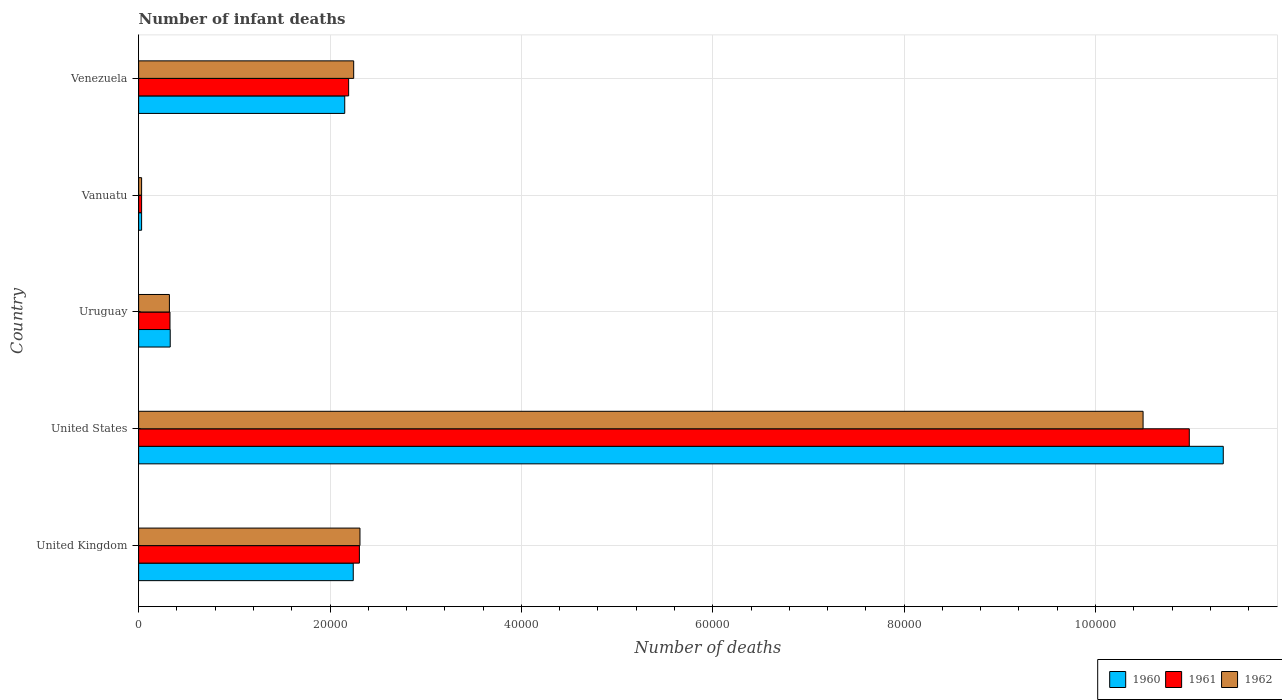Are the number of bars per tick equal to the number of legend labels?
Provide a short and direct response. Yes. Are the number of bars on each tick of the Y-axis equal?
Ensure brevity in your answer.  Yes. How many bars are there on the 4th tick from the top?
Your answer should be compact. 3. What is the label of the 4th group of bars from the top?
Give a very brief answer. United States. What is the number of infant deaths in 1961 in Uruguay?
Your answer should be very brief. 3277. Across all countries, what is the maximum number of infant deaths in 1960?
Offer a terse response. 1.13e+05. Across all countries, what is the minimum number of infant deaths in 1961?
Give a very brief answer. 311. In which country was the number of infant deaths in 1961 minimum?
Your answer should be compact. Vanuatu. What is the total number of infant deaths in 1961 in the graph?
Provide a short and direct response. 1.58e+05. What is the difference between the number of infant deaths in 1962 in United Kingdom and that in Uruguay?
Ensure brevity in your answer.  1.99e+04. What is the difference between the number of infant deaths in 1962 in United Kingdom and the number of infant deaths in 1961 in United States?
Offer a terse response. -8.67e+04. What is the average number of infant deaths in 1961 per country?
Ensure brevity in your answer.  3.17e+04. What is the difference between the number of infant deaths in 1960 and number of infant deaths in 1962 in United States?
Ensure brevity in your answer.  8380. What is the ratio of the number of infant deaths in 1961 in Uruguay to that in Venezuela?
Offer a terse response. 0.15. Is the difference between the number of infant deaths in 1960 in United States and Uruguay greater than the difference between the number of infant deaths in 1962 in United States and Uruguay?
Provide a succinct answer. Yes. What is the difference between the highest and the second highest number of infant deaths in 1960?
Offer a terse response. 9.09e+04. What is the difference between the highest and the lowest number of infant deaths in 1962?
Provide a short and direct response. 1.05e+05. In how many countries, is the number of infant deaths in 1960 greater than the average number of infant deaths in 1960 taken over all countries?
Offer a terse response. 1. Is the sum of the number of infant deaths in 1962 in United Kingdom and Venezuela greater than the maximum number of infant deaths in 1961 across all countries?
Offer a very short reply. No. What does the 3rd bar from the top in Venezuela represents?
Your response must be concise. 1960. What does the 2nd bar from the bottom in Venezuela represents?
Provide a short and direct response. 1961. What is the difference between two consecutive major ticks on the X-axis?
Make the answer very short. 2.00e+04. Does the graph contain any zero values?
Give a very brief answer. No. Where does the legend appear in the graph?
Offer a very short reply. Bottom right. How many legend labels are there?
Give a very brief answer. 3. How are the legend labels stacked?
Your answer should be compact. Horizontal. What is the title of the graph?
Your answer should be compact. Number of infant deaths. Does "2004" appear as one of the legend labels in the graph?
Ensure brevity in your answer.  No. What is the label or title of the X-axis?
Your response must be concise. Number of deaths. What is the label or title of the Y-axis?
Offer a terse response. Country. What is the Number of deaths in 1960 in United Kingdom?
Offer a very short reply. 2.24e+04. What is the Number of deaths of 1961 in United Kingdom?
Your answer should be very brief. 2.31e+04. What is the Number of deaths of 1962 in United Kingdom?
Offer a terse response. 2.31e+04. What is the Number of deaths of 1960 in United States?
Offer a very short reply. 1.13e+05. What is the Number of deaths of 1961 in United States?
Your answer should be very brief. 1.10e+05. What is the Number of deaths of 1962 in United States?
Your response must be concise. 1.05e+05. What is the Number of deaths in 1960 in Uruguay?
Give a very brief answer. 3301. What is the Number of deaths of 1961 in Uruguay?
Provide a short and direct response. 3277. What is the Number of deaths of 1962 in Uruguay?
Provide a short and direct response. 3216. What is the Number of deaths in 1960 in Vanuatu?
Give a very brief answer. 311. What is the Number of deaths of 1961 in Vanuatu?
Give a very brief answer. 311. What is the Number of deaths of 1962 in Vanuatu?
Give a very brief answer. 311. What is the Number of deaths in 1960 in Venezuela?
Your answer should be compact. 2.15e+04. What is the Number of deaths of 1961 in Venezuela?
Your response must be concise. 2.19e+04. What is the Number of deaths in 1962 in Venezuela?
Make the answer very short. 2.25e+04. Across all countries, what is the maximum Number of deaths of 1960?
Your answer should be very brief. 1.13e+05. Across all countries, what is the maximum Number of deaths in 1961?
Ensure brevity in your answer.  1.10e+05. Across all countries, what is the maximum Number of deaths of 1962?
Give a very brief answer. 1.05e+05. Across all countries, what is the minimum Number of deaths in 1960?
Keep it short and to the point. 311. Across all countries, what is the minimum Number of deaths of 1961?
Provide a short and direct response. 311. Across all countries, what is the minimum Number of deaths in 1962?
Keep it short and to the point. 311. What is the total Number of deaths of 1960 in the graph?
Offer a very short reply. 1.61e+05. What is the total Number of deaths in 1961 in the graph?
Offer a terse response. 1.58e+05. What is the total Number of deaths of 1962 in the graph?
Provide a succinct answer. 1.54e+05. What is the difference between the Number of deaths in 1960 in United Kingdom and that in United States?
Make the answer very short. -9.09e+04. What is the difference between the Number of deaths of 1961 in United Kingdom and that in United States?
Provide a short and direct response. -8.67e+04. What is the difference between the Number of deaths of 1962 in United Kingdom and that in United States?
Provide a succinct answer. -8.18e+04. What is the difference between the Number of deaths in 1960 in United Kingdom and that in Uruguay?
Offer a very short reply. 1.91e+04. What is the difference between the Number of deaths of 1961 in United Kingdom and that in Uruguay?
Provide a short and direct response. 1.98e+04. What is the difference between the Number of deaths of 1962 in United Kingdom and that in Uruguay?
Offer a very short reply. 1.99e+04. What is the difference between the Number of deaths of 1960 in United Kingdom and that in Vanuatu?
Offer a very short reply. 2.21e+04. What is the difference between the Number of deaths of 1961 in United Kingdom and that in Vanuatu?
Provide a succinct answer. 2.28e+04. What is the difference between the Number of deaths in 1962 in United Kingdom and that in Vanuatu?
Make the answer very short. 2.28e+04. What is the difference between the Number of deaths of 1960 in United Kingdom and that in Venezuela?
Your response must be concise. 890. What is the difference between the Number of deaths in 1961 in United Kingdom and that in Venezuela?
Keep it short and to the point. 1124. What is the difference between the Number of deaths of 1962 in United Kingdom and that in Venezuela?
Make the answer very short. 657. What is the difference between the Number of deaths in 1960 in United States and that in Uruguay?
Offer a terse response. 1.10e+05. What is the difference between the Number of deaths of 1961 in United States and that in Uruguay?
Make the answer very short. 1.07e+05. What is the difference between the Number of deaths in 1962 in United States and that in Uruguay?
Offer a very short reply. 1.02e+05. What is the difference between the Number of deaths in 1960 in United States and that in Vanuatu?
Offer a terse response. 1.13e+05. What is the difference between the Number of deaths of 1961 in United States and that in Vanuatu?
Ensure brevity in your answer.  1.09e+05. What is the difference between the Number of deaths of 1962 in United States and that in Vanuatu?
Your answer should be compact. 1.05e+05. What is the difference between the Number of deaths in 1960 in United States and that in Venezuela?
Provide a short and direct response. 9.18e+04. What is the difference between the Number of deaths of 1961 in United States and that in Venezuela?
Make the answer very short. 8.79e+04. What is the difference between the Number of deaths of 1962 in United States and that in Venezuela?
Ensure brevity in your answer.  8.25e+04. What is the difference between the Number of deaths of 1960 in Uruguay and that in Vanuatu?
Provide a short and direct response. 2990. What is the difference between the Number of deaths in 1961 in Uruguay and that in Vanuatu?
Offer a very short reply. 2966. What is the difference between the Number of deaths of 1962 in Uruguay and that in Vanuatu?
Ensure brevity in your answer.  2905. What is the difference between the Number of deaths in 1960 in Uruguay and that in Venezuela?
Give a very brief answer. -1.82e+04. What is the difference between the Number of deaths of 1961 in Uruguay and that in Venezuela?
Make the answer very short. -1.87e+04. What is the difference between the Number of deaths of 1962 in Uruguay and that in Venezuela?
Provide a short and direct response. -1.93e+04. What is the difference between the Number of deaths in 1960 in Vanuatu and that in Venezuela?
Provide a short and direct response. -2.12e+04. What is the difference between the Number of deaths in 1961 in Vanuatu and that in Venezuela?
Make the answer very short. -2.16e+04. What is the difference between the Number of deaths in 1962 in Vanuatu and that in Venezuela?
Offer a terse response. -2.22e+04. What is the difference between the Number of deaths of 1960 in United Kingdom and the Number of deaths of 1961 in United States?
Offer a very short reply. -8.74e+04. What is the difference between the Number of deaths in 1960 in United Kingdom and the Number of deaths in 1962 in United States?
Provide a succinct answer. -8.25e+04. What is the difference between the Number of deaths of 1961 in United Kingdom and the Number of deaths of 1962 in United States?
Keep it short and to the point. -8.19e+04. What is the difference between the Number of deaths in 1960 in United Kingdom and the Number of deaths in 1961 in Uruguay?
Make the answer very short. 1.92e+04. What is the difference between the Number of deaths of 1960 in United Kingdom and the Number of deaths of 1962 in Uruguay?
Offer a terse response. 1.92e+04. What is the difference between the Number of deaths of 1961 in United Kingdom and the Number of deaths of 1962 in Uruguay?
Offer a very short reply. 1.99e+04. What is the difference between the Number of deaths in 1960 in United Kingdom and the Number of deaths in 1961 in Vanuatu?
Your response must be concise. 2.21e+04. What is the difference between the Number of deaths of 1960 in United Kingdom and the Number of deaths of 1962 in Vanuatu?
Provide a short and direct response. 2.21e+04. What is the difference between the Number of deaths of 1961 in United Kingdom and the Number of deaths of 1962 in Vanuatu?
Make the answer very short. 2.28e+04. What is the difference between the Number of deaths in 1960 in United Kingdom and the Number of deaths in 1961 in Venezuela?
Provide a succinct answer. 482. What is the difference between the Number of deaths of 1960 in United Kingdom and the Number of deaths of 1962 in Venezuela?
Offer a very short reply. -45. What is the difference between the Number of deaths of 1961 in United Kingdom and the Number of deaths of 1962 in Venezuela?
Provide a succinct answer. 597. What is the difference between the Number of deaths in 1960 in United States and the Number of deaths in 1961 in Uruguay?
Provide a short and direct response. 1.10e+05. What is the difference between the Number of deaths of 1960 in United States and the Number of deaths of 1962 in Uruguay?
Make the answer very short. 1.10e+05. What is the difference between the Number of deaths of 1961 in United States and the Number of deaths of 1962 in Uruguay?
Your answer should be compact. 1.07e+05. What is the difference between the Number of deaths in 1960 in United States and the Number of deaths in 1961 in Vanuatu?
Make the answer very short. 1.13e+05. What is the difference between the Number of deaths of 1960 in United States and the Number of deaths of 1962 in Vanuatu?
Your answer should be very brief. 1.13e+05. What is the difference between the Number of deaths of 1961 in United States and the Number of deaths of 1962 in Vanuatu?
Offer a terse response. 1.09e+05. What is the difference between the Number of deaths in 1960 in United States and the Number of deaths in 1961 in Venezuela?
Offer a terse response. 9.14e+04. What is the difference between the Number of deaths of 1960 in United States and the Number of deaths of 1962 in Venezuela?
Offer a terse response. 9.09e+04. What is the difference between the Number of deaths of 1961 in United States and the Number of deaths of 1962 in Venezuela?
Keep it short and to the point. 8.73e+04. What is the difference between the Number of deaths of 1960 in Uruguay and the Number of deaths of 1961 in Vanuatu?
Ensure brevity in your answer.  2990. What is the difference between the Number of deaths of 1960 in Uruguay and the Number of deaths of 1962 in Vanuatu?
Provide a short and direct response. 2990. What is the difference between the Number of deaths in 1961 in Uruguay and the Number of deaths in 1962 in Vanuatu?
Give a very brief answer. 2966. What is the difference between the Number of deaths of 1960 in Uruguay and the Number of deaths of 1961 in Venezuela?
Provide a short and direct response. -1.86e+04. What is the difference between the Number of deaths in 1960 in Uruguay and the Number of deaths in 1962 in Venezuela?
Keep it short and to the point. -1.92e+04. What is the difference between the Number of deaths of 1961 in Uruguay and the Number of deaths of 1962 in Venezuela?
Provide a short and direct response. -1.92e+04. What is the difference between the Number of deaths of 1960 in Vanuatu and the Number of deaths of 1961 in Venezuela?
Provide a succinct answer. -2.16e+04. What is the difference between the Number of deaths in 1960 in Vanuatu and the Number of deaths in 1962 in Venezuela?
Make the answer very short. -2.22e+04. What is the difference between the Number of deaths of 1961 in Vanuatu and the Number of deaths of 1962 in Venezuela?
Keep it short and to the point. -2.22e+04. What is the average Number of deaths of 1960 per country?
Ensure brevity in your answer.  3.22e+04. What is the average Number of deaths in 1961 per country?
Your answer should be very brief. 3.17e+04. What is the average Number of deaths in 1962 per country?
Ensure brevity in your answer.  3.08e+04. What is the difference between the Number of deaths of 1960 and Number of deaths of 1961 in United Kingdom?
Keep it short and to the point. -642. What is the difference between the Number of deaths in 1960 and Number of deaths in 1962 in United Kingdom?
Provide a short and direct response. -702. What is the difference between the Number of deaths of 1961 and Number of deaths of 1962 in United Kingdom?
Your response must be concise. -60. What is the difference between the Number of deaths of 1960 and Number of deaths of 1961 in United States?
Ensure brevity in your answer.  3550. What is the difference between the Number of deaths in 1960 and Number of deaths in 1962 in United States?
Keep it short and to the point. 8380. What is the difference between the Number of deaths in 1961 and Number of deaths in 1962 in United States?
Offer a terse response. 4830. What is the difference between the Number of deaths of 1961 and Number of deaths of 1962 in Uruguay?
Make the answer very short. 61. What is the difference between the Number of deaths in 1960 and Number of deaths in 1961 in Vanuatu?
Offer a very short reply. 0. What is the difference between the Number of deaths in 1960 and Number of deaths in 1962 in Vanuatu?
Offer a terse response. 0. What is the difference between the Number of deaths of 1961 and Number of deaths of 1962 in Vanuatu?
Your response must be concise. 0. What is the difference between the Number of deaths of 1960 and Number of deaths of 1961 in Venezuela?
Make the answer very short. -408. What is the difference between the Number of deaths in 1960 and Number of deaths in 1962 in Venezuela?
Give a very brief answer. -935. What is the difference between the Number of deaths in 1961 and Number of deaths in 1962 in Venezuela?
Offer a terse response. -527. What is the ratio of the Number of deaths in 1960 in United Kingdom to that in United States?
Your answer should be compact. 0.2. What is the ratio of the Number of deaths in 1961 in United Kingdom to that in United States?
Give a very brief answer. 0.21. What is the ratio of the Number of deaths of 1962 in United Kingdom to that in United States?
Your answer should be very brief. 0.22. What is the ratio of the Number of deaths in 1960 in United Kingdom to that in Uruguay?
Your answer should be very brief. 6.79. What is the ratio of the Number of deaths of 1961 in United Kingdom to that in Uruguay?
Provide a short and direct response. 7.04. What is the ratio of the Number of deaths of 1962 in United Kingdom to that in Uruguay?
Provide a short and direct response. 7.19. What is the ratio of the Number of deaths in 1960 in United Kingdom to that in Vanuatu?
Your answer should be very brief. 72.12. What is the ratio of the Number of deaths of 1961 in United Kingdom to that in Vanuatu?
Ensure brevity in your answer.  74.19. What is the ratio of the Number of deaths of 1962 in United Kingdom to that in Vanuatu?
Make the answer very short. 74.38. What is the ratio of the Number of deaths in 1960 in United Kingdom to that in Venezuela?
Provide a succinct answer. 1.04. What is the ratio of the Number of deaths of 1961 in United Kingdom to that in Venezuela?
Your answer should be compact. 1.05. What is the ratio of the Number of deaths in 1962 in United Kingdom to that in Venezuela?
Your answer should be very brief. 1.03. What is the ratio of the Number of deaths in 1960 in United States to that in Uruguay?
Offer a very short reply. 34.34. What is the ratio of the Number of deaths of 1961 in United States to that in Uruguay?
Your response must be concise. 33.51. What is the ratio of the Number of deaths of 1962 in United States to that in Uruguay?
Provide a short and direct response. 32.64. What is the ratio of the Number of deaths in 1960 in United States to that in Vanuatu?
Offer a very short reply. 364.48. What is the ratio of the Number of deaths of 1961 in United States to that in Vanuatu?
Ensure brevity in your answer.  353.07. What is the ratio of the Number of deaths of 1962 in United States to that in Vanuatu?
Your answer should be compact. 337.54. What is the ratio of the Number of deaths in 1960 in United States to that in Venezuela?
Give a very brief answer. 5.26. What is the ratio of the Number of deaths of 1961 in United States to that in Venezuela?
Keep it short and to the point. 5. What is the ratio of the Number of deaths of 1962 in United States to that in Venezuela?
Your answer should be compact. 4.67. What is the ratio of the Number of deaths of 1960 in Uruguay to that in Vanuatu?
Your response must be concise. 10.61. What is the ratio of the Number of deaths of 1961 in Uruguay to that in Vanuatu?
Your answer should be compact. 10.54. What is the ratio of the Number of deaths of 1962 in Uruguay to that in Vanuatu?
Provide a succinct answer. 10.34. What is the ratio of the Number of deaths in 1960 in Uruguay to that in Venezuela?
Your answer should be compact. 0.15. What is the ratio of the Number of deaths in 1961 in Uruguay to that in Venezuela?
Offer a terse response. 0.15. What is the ratio of the Number of deaths in 1962 in Uruguay to that in Venezuela?
Keep it short and to the point. 0.14. What is the ratio of the Number of deaths of 1960 in Vanuatu to that in Venezuela?
Ensure brevity in your answer.  0.01. What is the ratio of the Number of deaths of 1961 in Vanuatu to that in Venezuela?
Give a very brief answer. 0.01. What is the ratio of the Number of deaths in 1962 in Vanuatu to that in Venezuela?
Your answer should be compact. 0.01. What is the difference between the highest and the second highest Number of deaths of 1960?
Your answer should be compact. 9.09e+04. What is the difference between the highest and the second highest Number of deaths of 1961?
Ensure brevity in your answer.  8.67e+04. What is the difference between the highest and the second highest Number of deaths in 1962?
Your answer should be very brief. 8.18e+04. What is the difference between the highest and the lowest Number of deaths in 1960?
Make the answer very short. 1.13e+05. What is the difference between the highest and the lowest Number of deaths in 1961?
Give a very brief answer. 1.09e+05. What is the difference between the highest and the lowest Number of deaths of 1962?
Keep it short and to the point. 1.05e+05. 